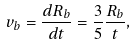Convert formula to latex. <formula><loc_0><loc_0><loc_500><loc_500>v _ { b } = \frac { d R _ { b } } { d t } = \frac { 3 } { 5 } \frac { R _ { b } } { t } ,</formula> 